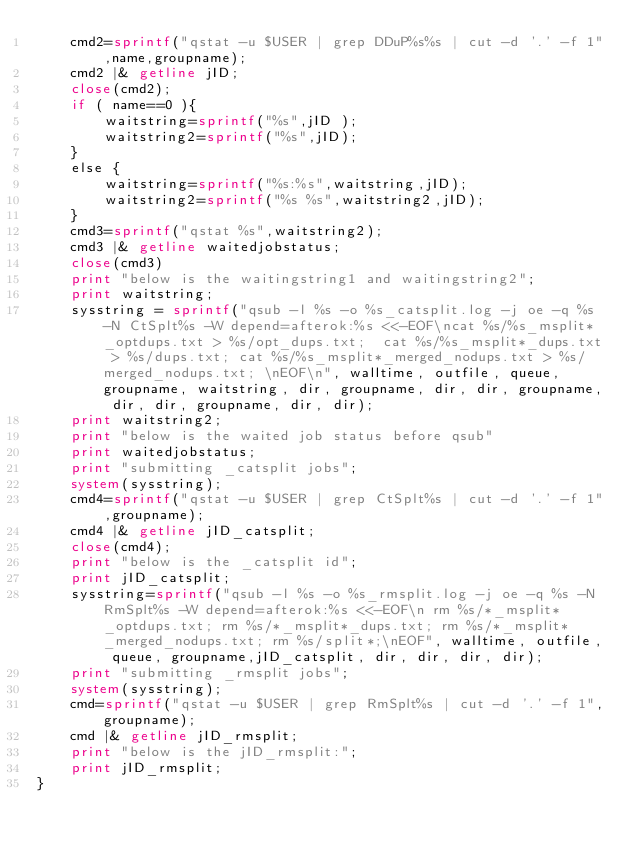Convert code to text. <code><loc_0><loc_0><loc_500><loc_500><_Awk_>	cmd2=sprintf("qstat -u $USER | grep DDuP%s%s | cut -d '.' -f 1",name,groupname);
	cmd2 |& getline jID;
	close(cmd2);
	if ( name==0 ){
		waitstring=sprintf("%s",jID );
		waitstring2=sprintf("%s",jID);
	}
	else {
		waitstring=sprintf("%s:%s",waitstring,jID);
		waitstring2=sprintf("%s %s",waitstring2,jID);
	}
	cmd3=sprintf("qstat %s",waitstring2);
	cmd3 |& getline waitedjobstatus;
	close(cmd3)
	print "below is the waitingstring1 and waitingstring2";
	print waitstring;
	sysstring = sprintf("qsub -l %s -o %s_catsplit.log -j oe -q %s -N CtSplt%s -W depend=afterok:%s <<-EOF\ncat %s/%s_msplit*_optdups.txt > %s/opt_dups.txt;  cat %s/%s_msplit*_dups.txt > %s/dups.txt; cat %s/%s_msplit*_merged_nodups.txt > %s/merged_nodups.txt; \nEOF\n", walltime, outfile, queue, groupname, waitstring, dir, groupname, dir, dir, groupname, dir, dir, groupname, dir, dir);
	print waitstring2;
	print "below is the waited job status before qsub"
	print waitedjobstatus;
	print "submitting _catsplit jobs";
	system(sysstring);
	cmd4=sprintf("qstat -u $USER | grep CtSplt%s | cut -d '.' -f 1",groupname);
	cmd4 |& getline jID_catsplit;
	close(cmd4);
	print "below is the _catsplit id";
	print jID_catsplit;
	sysstring=sprintf("qsub -l %s -o %s_rmsplit.log -j oe -q %s -N RmSplt%s -W depend=afterok:%s <<-EOF\n rm %s/*_msplit*_optdups.txt; rm %s/*_msplit*_dups.txt; rm %s/*_msplit*_merged_nodups.txt; rm %s/split*;\nEOF", walltime, outfile, queue, groupname,jID_catsplit, dir, dir, dir, dir);
	print "submitting _rmsplit jobs";
	system(sysstring);
	cmd=sprintf("qstat -u $USER | grep RmSplt%s | cut -d '.' -f 1",groupname);
	cmd |& getline jID_rmsplit;
	print "below is the jID_rmsplit:";
	print jID_rmsplit;
}
</code> 